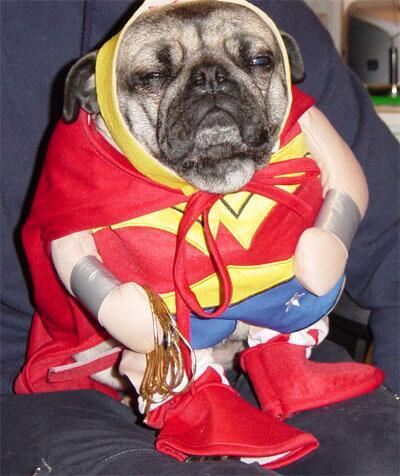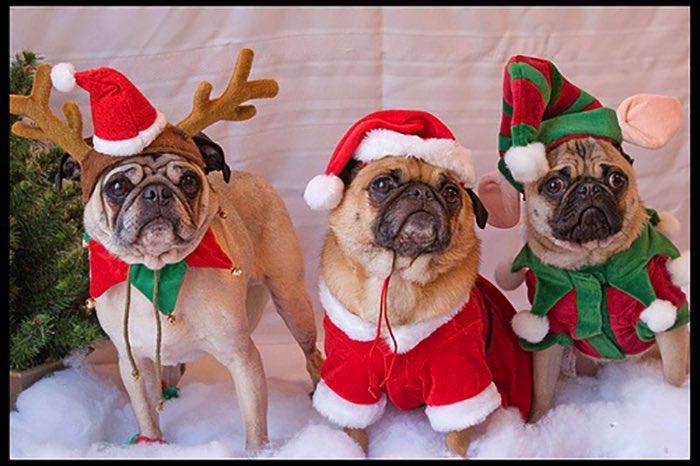The first image is the image on the left, the second image is the image on the right. For the images displayed, is the sentence "In one image, there are two pugs in a container that has a paper on it with printed text." factually correct? Answer yes or no. No. The first image is the image on the left, the second image is the image on the right. Given the left and right images, does the statement "An image shows two costumed pug dogs inside a container." hold true? Answer yes or no. No. 